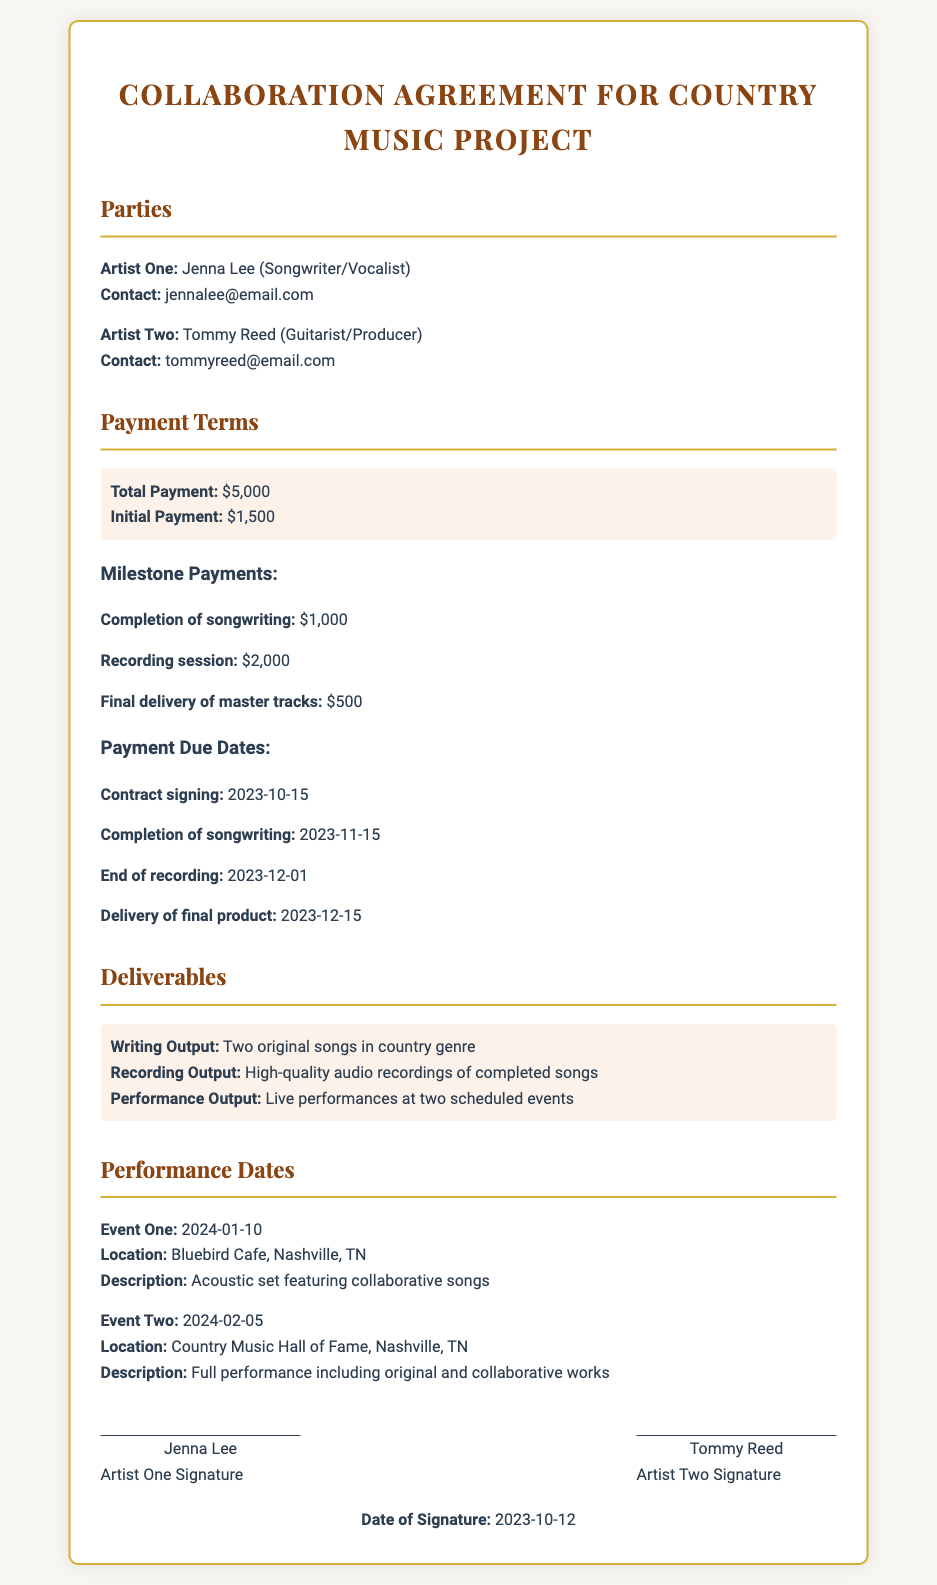what is the total payment? The total payment is clearly stated in the document, which shows it as $5,000.
Answer: $5,000 who is Artist One? The document identifies Artist One as Jenna Lee, including her role as a songwriter/vocalist.
Answer: Jenna Lee when is the completion of songwriting due? The due date for the completion of songwriting is specified in the payment section of the document as November 15, 2023.
Answer: 2023-11-15 what is the payment for the final delivery of master tracks? The document states that the payment for the final delivery of master tracks is $500.
Answer: $500 where will the first performance take place? The first performance location is provided in the performance dates section as Bluebird Cafe, Nashville, TN.
Answer: Bluebird Cafe, Nashville, TN how many original songs are required as deliverables? The deliverables section of the document specifies that two original songs are required.
Answer: Two original songs what is the date of signature? The document mentions the date of signature as October 12, 2023.
Answer: 2023-10-12 who is responsible for producing the music? The document identifies Tommy Reed as the guitarist/producer, indicating his role in production.
Answer: Tommy Reed what is the initial payment amount? The initial payment amount is stated in the payment terms as $1,500.
Answer: $1,500 when is the end of recording scheduled? The end of recording is scheduled as per the payment terms in the document on December 1, 2023.
Answer: 2023-12-01 